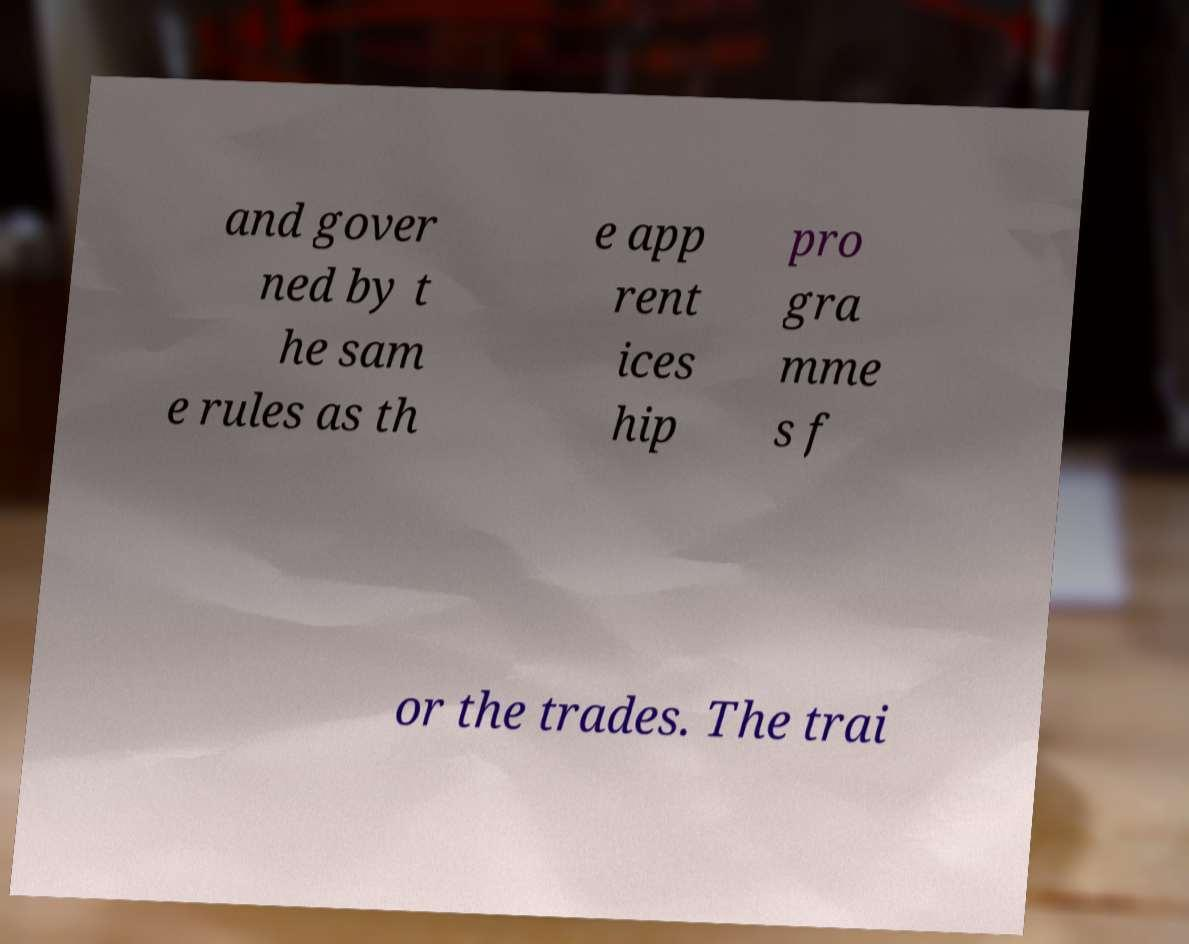Could you extract and type out the text from this image? and gover ned by t he sam e rules as th e app rent ices hip pro gra mme s f or the trades. The trai 